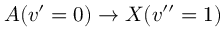Convert formula to latex. <formula><loc_0><loc_0><loc_500><loc_500>A ( v ^ { \prime } = 0 ) \rightarrow X ( v ^ { \prime \prime } = 1 )</formula> 